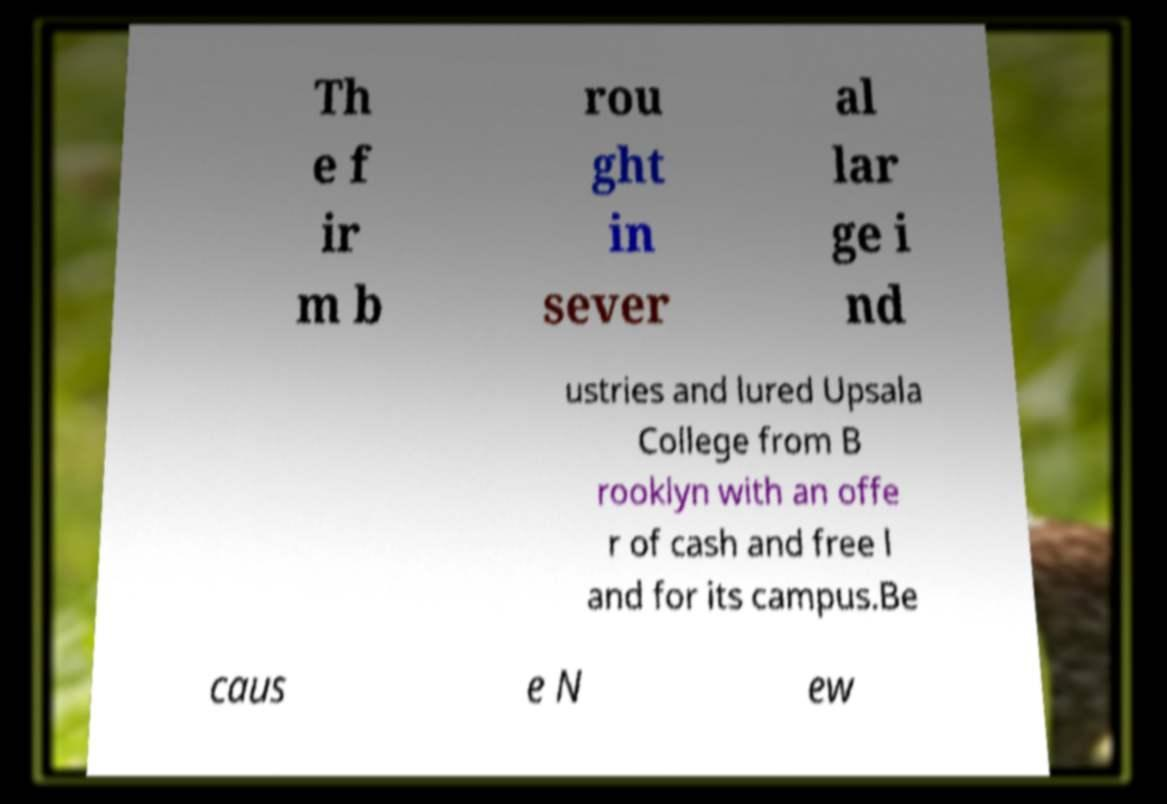Please identify and transcribe the text found in this image. Th e f ir m b rou ght in sever al lar ge i nd ustries and lured Upsala College from B rooklyn with an offe r of cash and free l and for its campus.Be caus e N ew 